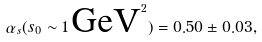Convert formula to latex. <formula><loc_0><loc_0><loc_500><loc_500>\alpha _ { s } ( s _ { 0 } \sim 1 \, \text {GeV} ^ { 2 } ) = 0 . 5 0 \pm 0 . 0 3 ,</formula> 